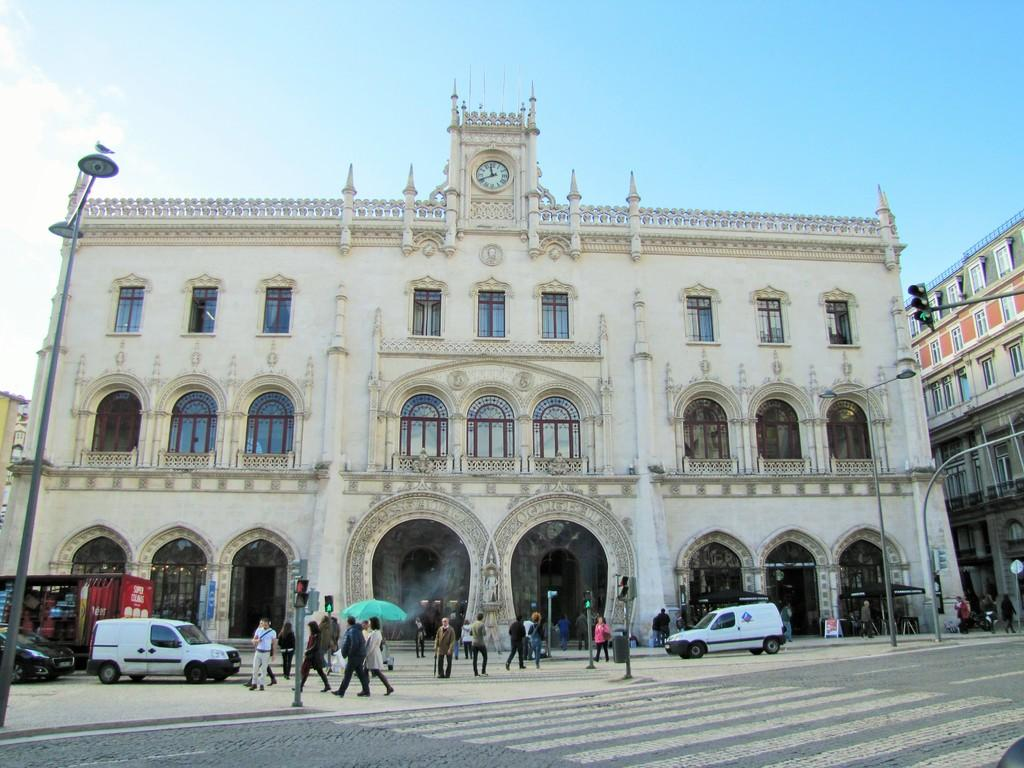What are the people in the image doing? There is a group of people walking on the street in the image. What can be seen controlling the traffic in the image? There are signal lights in the image. What are the lights attached to in the image? The lights are attached to poles in the image. What type of structures can be seen in the image? There are buildings in the image. What else is present on the street besides the people? There are vehicles in the image. What is visible in the background of the image? The sky is visible in the background of the image. What shape is the rabbit in the image? There is no rabbit present in the image. What idea does the group of people have in the image? The image does not provide information about the group's ideas or thoughts. 